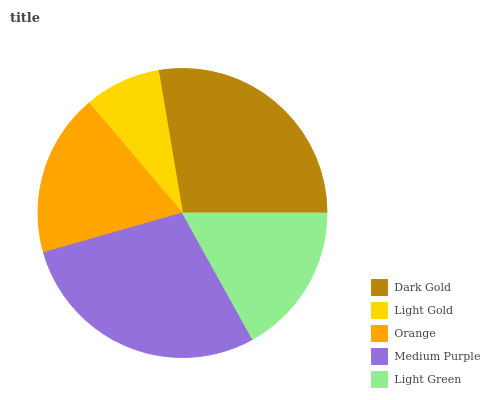Is Light Gold the minimum?
Answer yes or no. Yes. Is Medium Purple the maximum?
Answer yes or no. Yes. Is Orange the minimum?
Answer yes or no. No. Is Orange the maximum?
Answer yes or no. No. Is Orange greater than Light Gold?
Answer yes or no. Yes. Is Light Gold less than Orange?
Answer yes or no. Yes. Is Light Gold greater than Orange?
Answer yes or no. No. Is Orange less than Light Gold?
Answer yes or no. No. Is Orange the high median?
Answer yes or no. Yes. Is Orange the low median?
Answer yes or no. Yes. Is Light Green the high median?
Answer yes or no. No. Is Medium Purple the low median?
Answer yes or no. No. 